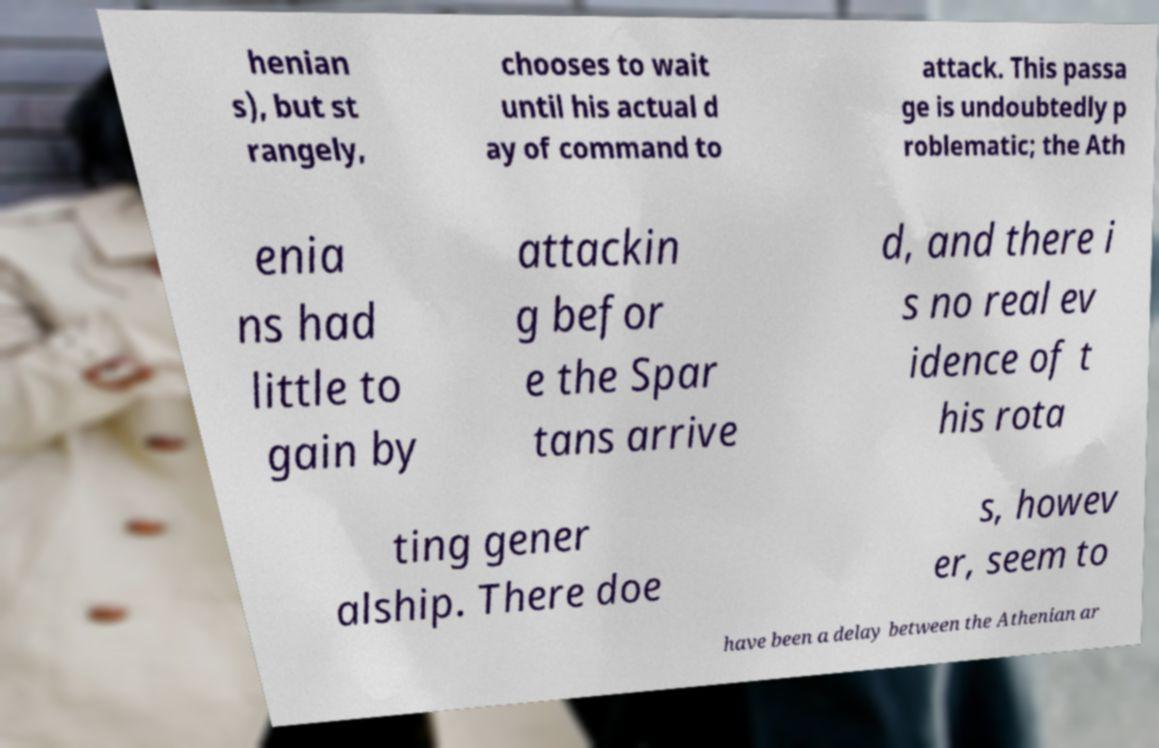Please read and relay the text visible in this image. What does it say? henian s), but st rangely, chooses to wait until his actual d ay of command to attack. This passa ge is undoubtedly p roblematic; the Ath enia ns had little to gain by attackin g befor e the Spar tans arrive d, and there i s no real ev idence of t his rota ting gener alship. There doe s, howev er, seem to have been a delay between the Athenian ar 